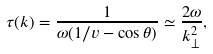Convert formula to latex. <formula><loc_0><loc_0><loc_500><loc_500>\tau ( k ) = \frac { 1 } { \omega ( 1 / v - \cos \theta ) } \simeq \frac { 2 \omega } { k ^ { 2 } _ { \perp } } ,</formula> 